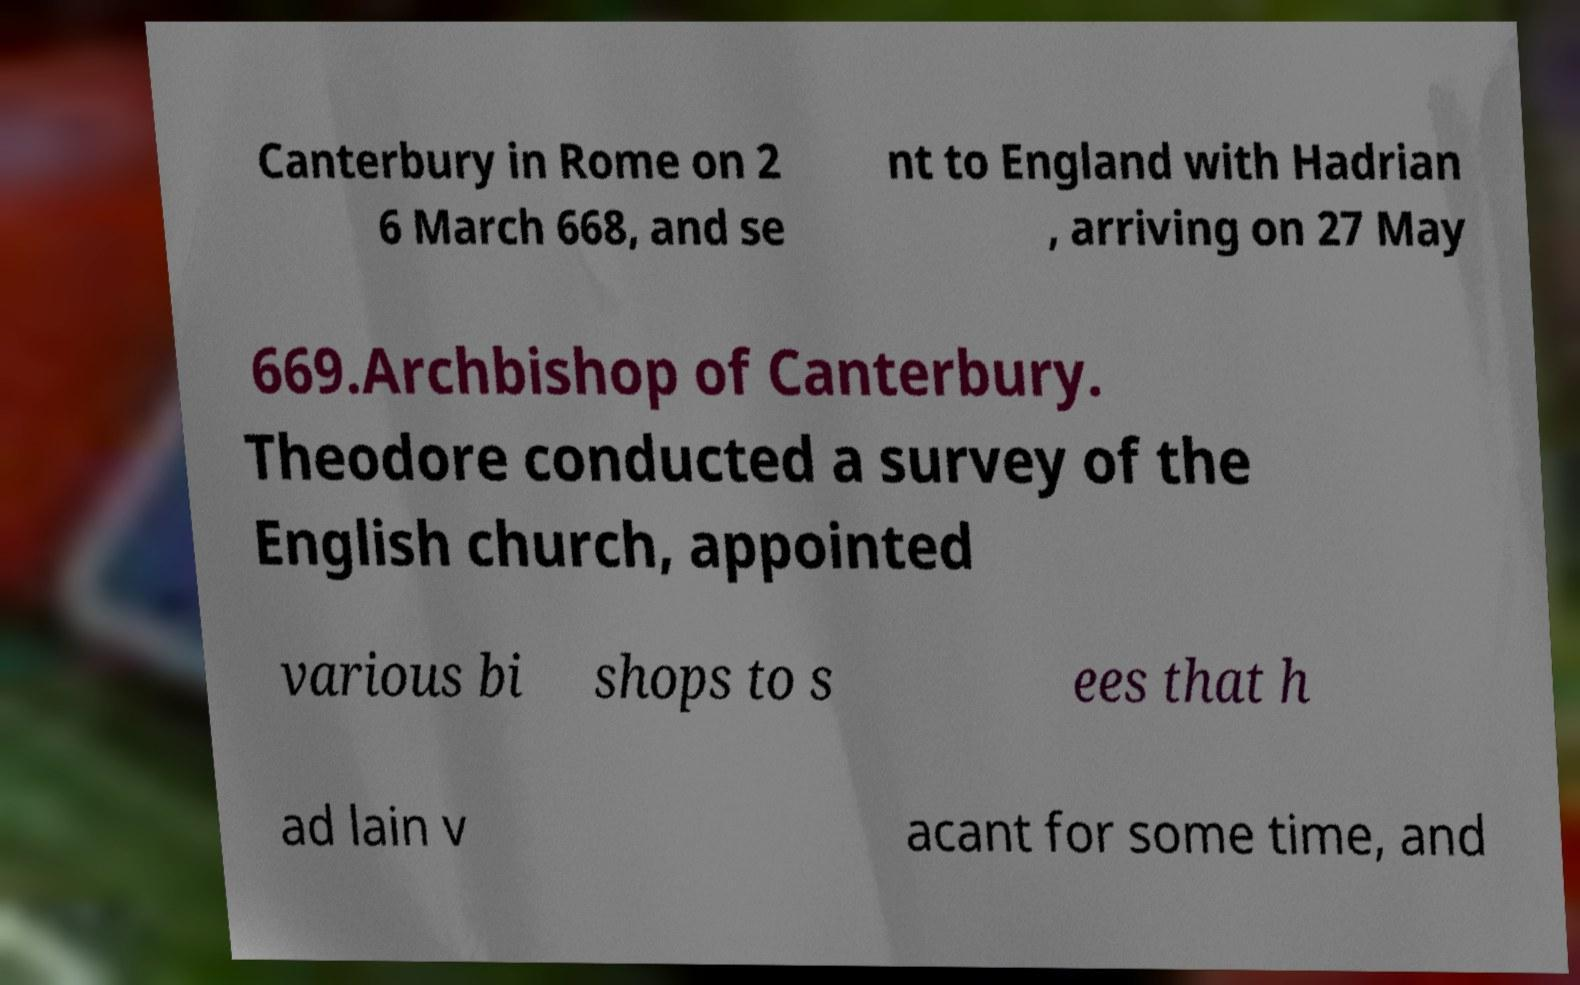Can you read and provide the text displayed in the image?This photo seems to have some interesting text. Can you extract and type it out for me? Canterbury in Rome on 2 6 March 668, and se nt to England with Hadrian , arriving on 27 May 669.Archbishop of Canterbury. Theodore conducted a survey of the English church, appointed various bi shops to s ees that h ad lain v acant for some time, and 